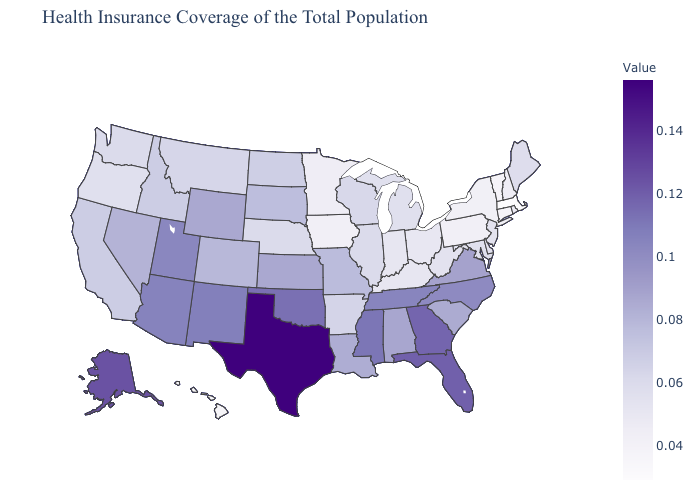Does Texas have the highest value in the South?
Be succinct. Yes. Which states have the lowest value in the South?
Be succinct. Kentucky. Does North Carolina have a lower value than Florida?
Concise answer only. Yes. 